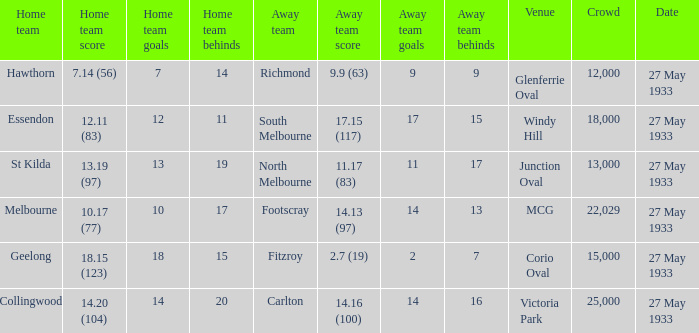During st kilda's home game, what was the number of people in the crowd? 13000.0. Can you parse all the data within this table? {'header': ['Home team', 'Home team score', 'Home team goals', 'Home team behinds', 'Away team', 'Away team score', 'Away team goals', 'Away team behinds', 'Venue', 'Crowd', 'Date'], 'rows': [['Hawthorn', '7.14 (56)', '7', '14', 'Richmond', '9.9 (63)', '9', '9', 'Glenferrie Oval', '12,000', '27 May 1933'], ['Essendon', '12.11 (83)', '12', '11', 'South Melbourne', '17.15 (117)', '17', '15', 'Windy Hill', '18,000', '27 May 1933'], ['St Kilda', '13.19 (97)', '13', '19', 'North Melbourne', '11.17 (83)', '11', '17', 'Junction Oval', '13,000', '27 May 1933'], ['Melbourne', '10.17 (77)', '10', '17', 'Footscray', '14.13 (97)', '14', '13', 'MCG', '22,029', '27 May 1933'], ['Geelong', '18.15 (123)', '18', '15', 'Fitzroy', '2.7 (19)', '2', '7', 'Corio Oval', '15,000', '27 May 1933'], ['Collingwood', '14.20 (104)', '14', '20', 'Carlton', '14.16 (100)', '14', '16', 'Victoria Park', '25,000', '27 May 1933']]} 